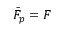<formula> <loc_0><loc_0><loc_500><loc_500>\bar { F } _ { p } = F</formula> 